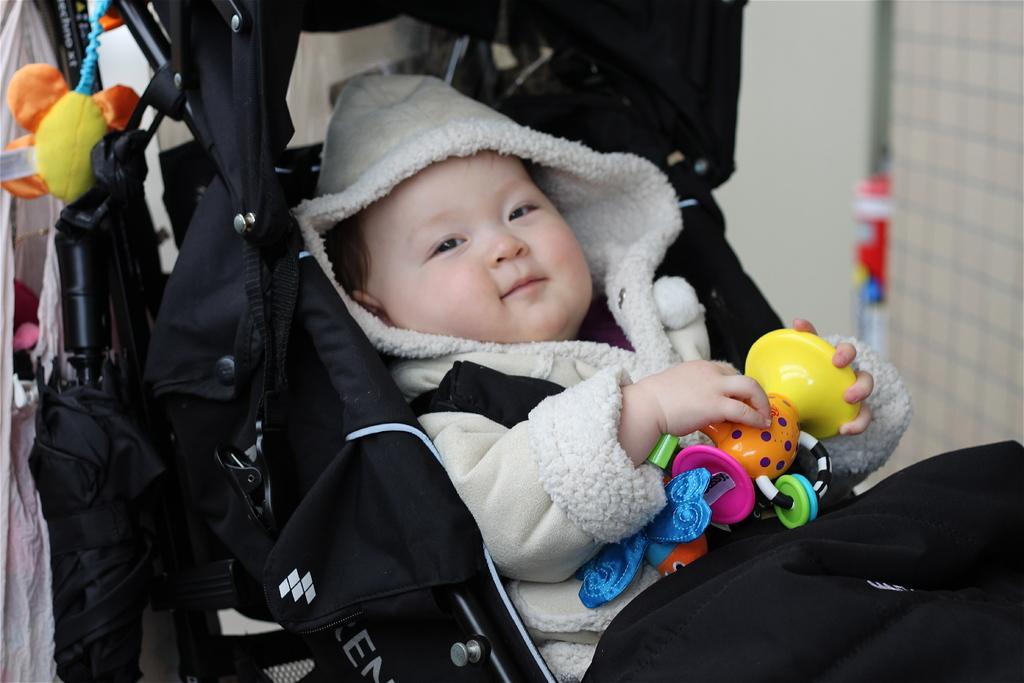Describe this image in one or two sentences. In this picture I can see a baby holding a toy and lying in a stroller, and in the background there are some objects. 